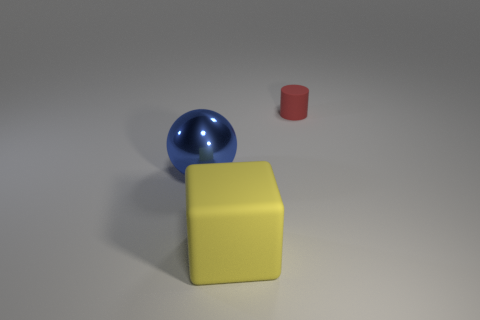Is there any other thing that is the same size as the matte cylinder?
Your answer should be compact. No. Is there anything else that has the same material as the blue ball?
Keep it short and to the point. No. There is a object in front of the big object behind the big yellow rubber block; what color is it?
Offer a terse response. Yellow. Are there the same number of yellow blocks that are on the left side of the big sphere and big matte objects to the left of the rubber cube?
Offer a terse response. Yes. Is the object that is behind the big metallic thing made of the same material as the big yellow object?
Your answer should be very brief. Yes. What is the color of the thing that is both behind the big yellow cube and on the left side of the matte cylinder?
Provide a short and direct response. Blue. What number of rubber things are in front of the small object behind the big sphere?
Ensure brevity in your answer.  1. The block has what color?
Give a very brief answer. Yellow. What number of objects are small brown cubes or big yellow matte blocks?
Offer a terse response. 1. There is a rubber thing to the right of the large block right of the metal sphere; what shape is it?
Offer a very short reply. Cylinder. 